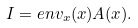<formula> <loc_0><loc_0><loc_500><loc_500>I = e n v _ { x } ( x ) A ( x ) .</formula> 